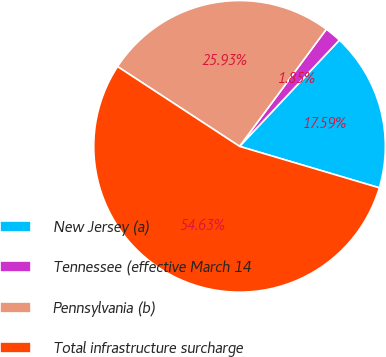Convert chart. <chart><loc_0><loc_0><loc_500><loc_500><pie_chart><fcel>New Jersey (a)<fcel>Tennessee (effective March 14<fcel>Pennsylvania (b)<fcel>Total infrastructure surcharge<nl><fcel>17.59%<fcel>1.85%<fcel>25.93%<fcel>54.63%<nl></chart> 